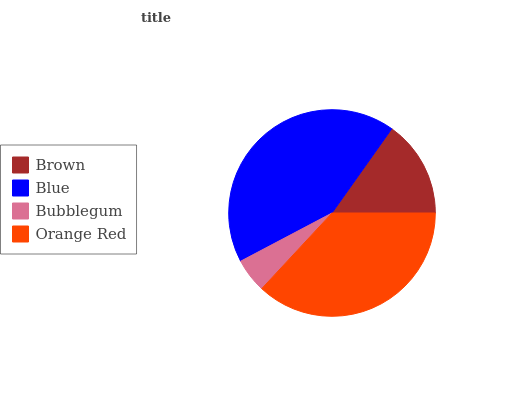Is Bubblegum the minimum?
Answer yes or no. Yes. Is Blue the maximum?
Answer yes or no. Yes. Is Blue the minimum?
Answer yes or no. No. Is Bubblegum the maximum?
Answer yes or no. No. Is Blue greater than Bubblegum?
Answer yes or no. Yes. Is Bubblegum less than Blue?
Answer yes or no. Yes. Is Bubblegum greater than Blue?
Answer yes or no. No. Is Blue less than Bubblegum?
Answer yes or no. No. Is Orange Red the high median?
Answer yes or no. Yes. Is Brown the low median?
Answer yes or no. Yes. Is Blue the high median?
Answer yes or no. No. Is Bubblegum the low median?
Answer yes or no. No. 